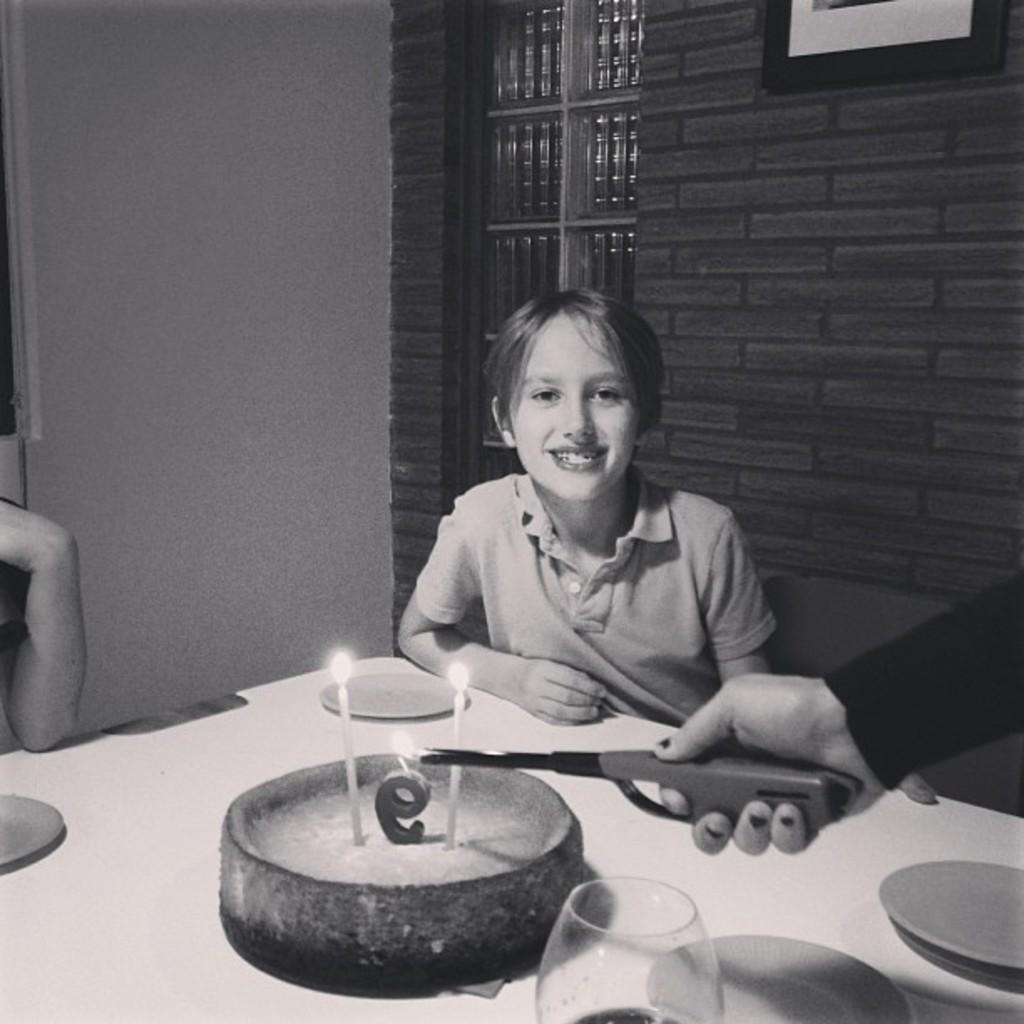Who is the main subject in the picture? There is a small boy in the picture. What is the boy doing in the picture? The boy is sitting and smiling. What is located in front of the boy on a table? There is a cake in front of the boy on a table. What type of songs is the boy attempting to sing in the picture? There is no indication in the image that the boy is attempting to sing any songs. 